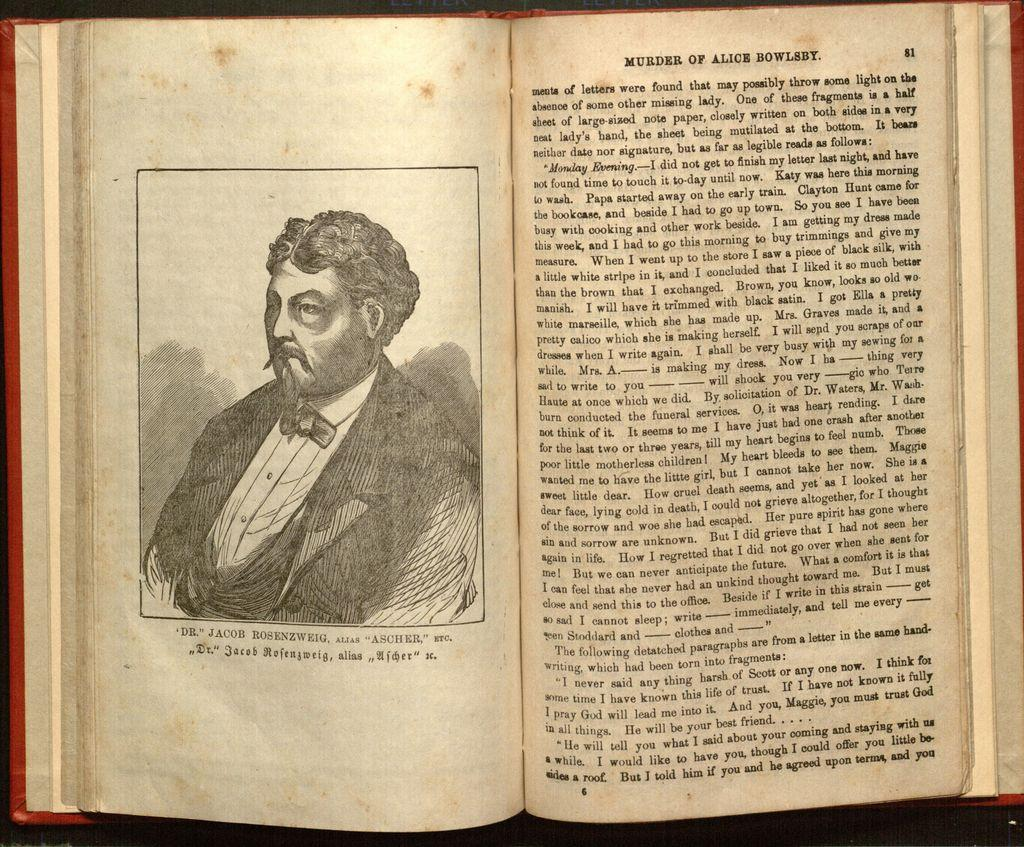<image>
Present a compact description of the photo's key features. A portrait of a man in a book titled Murder of Alice Bowlest. 